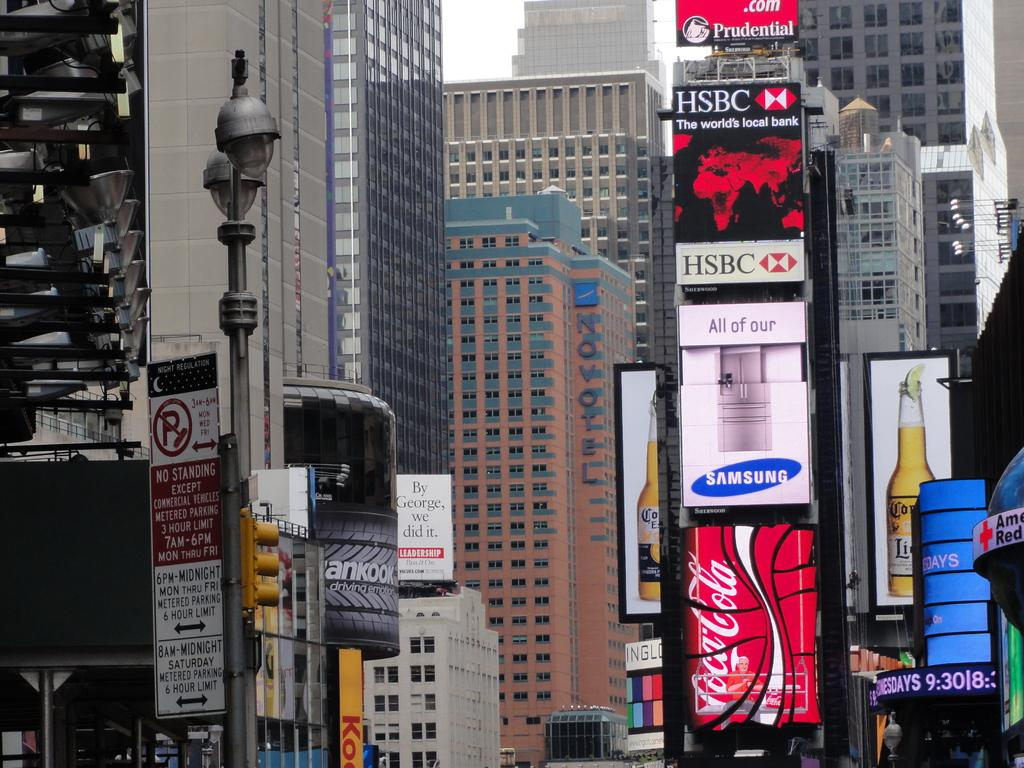What is the main subject of the image? The main subject of the image is the many buildings. Where is the pole signal located in the image? The pole signal is on the left side of the image. What can be seen in the background of the image? The sky is visible in the background of the image. What type of insect can be seen crawling on the buildings in the image? There are no insects visible in the image; it features many buildings and a pole signal. What color is the sweater worn by the buildings in the image? Buildings do not wear sweaters, so this question cannot be answered. 